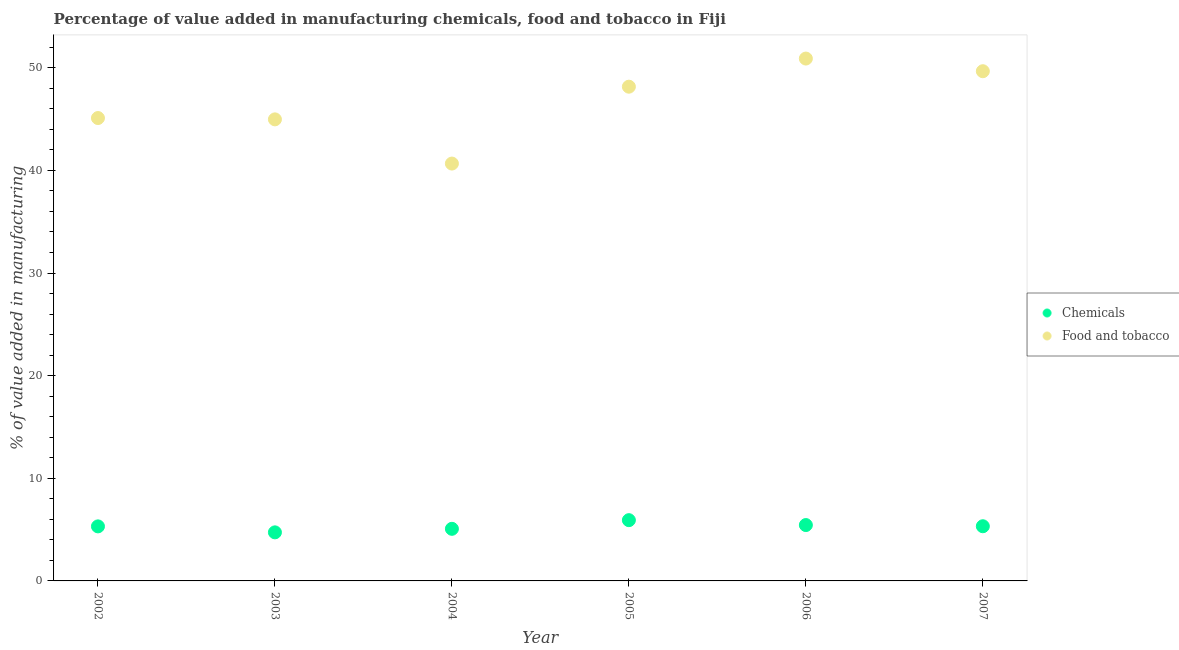How many different coloured dotlines are there?
Ensure brevity in your answer.  2. What is the value added by  manufacturing chemicals in 2003?
Provide a succinct answer. 4.73. Across all years, what is the maximum value added by  manufacturing chemicals?
Provide a short and direct response. 5.92. Across all years, what is the minimum value added by manufacturing food and tobacco?
Provide a succinct answer. 40.67. In which year was the value added by  manufacturing chemicals maximum?
Offer a very short reply. 2005. What is the total value added by  manufacturing chemicals in the graph?
Offer a very short reply. 31.82. What is the difference between the value added by manufacturing food and tobacco in 2002 and that in 2006?
Your answer should be compact. -5.79. What is the difference between the value added by  manufacturing chemicals in 2003 and the value added by manufacturing food and tobacco in 2004?
Your response must be concise. -35.94. What is the average value added by  manufacturing chemicals per year?
Ensure brevity in your answer.  5.3. In the year 2007, what is the difference between the value added by  manufacturing chemicals and value added by manufacturing food and tobacco?
Offer a very short reply. -44.34. In how many years, is the value added by  manufacturing chemicals greater than 46 %?
Your answer should be very brief. 0. What is the ratio of the value added by  manufacturing chemicals in 2005 to that in 2006?
Offer a terse response. 1.09. Is the difference between the value added by  manufacturing chemicals in 2002 and 2005 greater than the difference between the value added by manufacturing food and tobacco in 2002 and 2005?
Your answer should be very brief. Yes. What is the difference between the highest and the second highest value added by  manufacturing chemicals?
Your response must be concise. 0.48. What is the difference between the highest and the lowest value added by manufacturing food and tobacco?
Offer a very short reply. 10.23. Is the sum of the value added by manufacturing food and tobacco in 2002 and 2004 greater than the maximum value added by  manufacturing chemicals across all years?
Keep it short and to the point. Yes. How many dotlines are there?
Keep it short and to the point. 2. How many years are there in the graph?
Your response must be concise. 6. What is the difference between two consecutive major ticks on the Y-axis?
Your answer should be very brief. 10. Where does the legend appear in the graph?
Provide a succinct answer. Center right. How many legend labels are there?
Your answer should be compact. 2. How are the legend labels stacked?
Your answer should be very brief. Vertical. What is the title of the graph?
Make the answer very short. Percentage of value added in manufacturing chemicals, food and tobacco in Fiji. What is the label or title of the X-axis?
Provide a succinct answer. Year. What is the label or title of the Y-axis?
Make the answer very short. % of value added in manufacturing. What is the % of value added in manufacturing of Chemicals in 2002?
Ensure brevity in your answer.  5.31. What is the % of value added in manufacturing of Food and tobacco in 2002?
Your answer should be very brief. 45.1. What is the % of value added in manufacturing of Chemicals in 2003?
Keep it short and to the point. 4.73. What is the % of value added in manufacturing of Food and tobacco in 2003?
Keep it short and to the point. 44.97. What is the % of value added in manufacturing in Chemicals in 2004?
Provide a succinct answer. 5.08. What is the % of value added in manufacturing in Food and tobacco in 2004?
Your answer should be compact. 40.67. What is the % of value added in manufacturing in Chemicals in 2005?
Give a very brief answer. 5.92. What is the % of value added in manufacturing of Food and tobacco in 2005?
Make the answer very short. 48.16. What is the % of value added in manufacturing of Chemicals in 2006?
Provide a short and direct response. 5.44. What is the % of value added in manufacturing in Food and tobacco in 2006?
Offer a terse response. 50.9. What is the % of value added in manufacturing in Chemicals in 2007?
Provide a succinct answer. 5.33. What is the % of value added in manufacturing of Food and tobacco in 2007?
Your response must be concise. 49.67. Across all years, what is the maximum % of value added in manufacturing in Chemicals?
Your answer should be very brief. 5.92. Across all years, what is the maximum % of value added in manufacturing in Food and tobacco?
Offer a very short reply. 50.9. Across all years, what is the minimum % of value added in manufacturing of Chemicals?
Provide a succinct answer. 4.73. Across all years, what is the minimum % of value added in manufacturing of Food and tobacco?
Provide a succinct answer. 40.67. What is the total % of value added in manufacturing in Chemicals in the graph?
Your answer should be very brief. 31.82. What is the total % of value added in manufacturing in Food and tobacco in the graph?
Give a very brief answer. 279.47. What is the difference between the % of value added in manufacturing of Chemicals in 2002 and that in 2003?
Give a very brief answer. 0.58. What is the difference between the % of value added in manufacturing in Food and tobacco in 2002 and that in 2003?
Offer a terse response. 0.13. What is the difference between the % of value added in manufacturing of Chemicals in 2002 and that in 2004?
Your answer should be very brief. 0.24. What is the difference between the % of value added in manufacturing in Food and tobacco in 2002 and that in 2004?
Keep it short and to the point. 4.44. What is the difference between the % of value added in manufacturing in Chemicals in 2002 and that in 2005?
Make the answer very short. -0.61. What is the difference between the % of value added in manufacturing of Food and tobacco in 2002 and that in 2005?
Make the answer very short. -3.05. What is the difference between the % of value added in manufacturing of Chemicals in 2002 and that in 2006?
Your response must be concise. -0.13. What is the difference between the % of value added in manufacturing of Food and tobacco in 2002 and that in 2006?
Your answer should be very brief. -5.79. What is the difference between the % of value added in manufacturing of Chemicals in 2002 and that in 2007?
Make the answer very short. -0.01. What is the difference between the % of value added in manufacturing of Food and tobacco in 2002 and that in 2007?
Offer a terse response. -4.56. What is the difference between the % of value added in manufacturing in Chemicals in 2003 and that in 2004?
Provide a short and direct response. -0.34. What is the difference between the % of value added in manufacturing in Food and tobacco in 2003 and that in 2004?
Your response must be concise. 4.31. What is the difference between the % of value added in manufacturing in Chemicals in 2003 and that in 2005?
Give a very brief answer. -1.19. What is the difference between the % of value added in manufacturing in Food and tobacco in 2003 and that in 2005?
Provide a short and direct response. -3.18. What is the difference between the % of value added in manufacturing in Chemicals in 2003 and that in 2006?
Ensure brevity in your answer.  -0.71. What is the difference between the % of value added in manufacturing of Food and tobacco in 2003 and that in 2006?
Give a very brief answer. -5.92. What is the difference between the % of value added in manufacturing in Chemicals in 2003 and that in 2007?
Keep it short and to the point. -0.6. What is the difference between the % of value added in manufacturing of Food and tobacco in 2003 and that in 2007?
Keep it short and to the point. -4.69. What is the difference between the % of value added in manufacturing in Chemicals in 2004 and that in 2005?
Offer a terse response. -0.84. What is the difference between the % of value added in manufacturing in Food and tobacco in 2004 and that in 2005?
Your answer should be very brief. -7.49. What is the difference between the % of value added in manufacturing in Chemicals in 2004 and that in 2006?
Your answer should be very brief. -0.37. What is the difference between the % of value added in manufacturing of Food and tobacco in 2004 and that in 2006?
Offer a very short reply. -10.23. What is the difference between the % of value added in manufacturing of Chemicals in 2004 and that in 2007?
Provide a succinct answer. -0.25. What is the difference between the % of value added in manufacturing of Food and tobacco in 2004 and that in 2007?
Offer a terse response. -9. What is the difference between the % of value added in manufacturing of Chemicals in 2005 and that in 2006?
Your response must be concise. 0.48. What is the difference between the % of value added in manufacturing in Food and tobacco in 2005 and that in 2006?
Offer a terse response. -2.74. What is the difference between the % of value added in manufacturing of Chemicals in 2005 and that in 2007?
Your answer should be very brief. 0.59. What is the difference between the % of value added in manufacturing in Food and tobacco in 2005 and that in 2007?
Offer a terse response. -1.51. What is the difference between the % of value added in manufacturing of Chemicals in 2006 and that in 2007?
Give a very brief answer. 0.12. What is the difference between the % of value added in manufacturing of Food and tobacco in 2006 and that in 2007?
Your answer should be very brief. 1.23. What is the difference between the % of value added in manufacturing of Chemicals in 2002 and the % of value added in manufacturing of Food and tobacco in 2003?
Give a very brief answer. -39.66. What is the difference between the % of value added in manufacturing in Chemicals in 2002 and the % of value added in manufacturing in Food and tobacco in 2004?
Keep it short and to the point. -35.35. What is the difference between the % of value added in manufacturing in Chemicals in 2002 and the % of value added in manufacturing in Food and tobacco in 2005?
Give a very brief answer. -42.84. What is the difference between the % of value added in manufacturing in Chemicals in 2002 and the % of value added in manufacturing in Food and tobacco in 2006?
Your answer should be very brief. -45.58. What is the difference between the % of value added in manufacturing in Chemicals in 2002 and the % of value added in manufacturing in Food and tobacco in 2007?
Offer a terse response. -44.35. What is the difference between the % of value added in manufacturing of Chemicals in 2003 and the % of value added in manufacturing of Food and tobacco in 2004?
Offer a very short reply. -35.94. What is the difference between the % of value added in manufacturing in Chemicals in 2003 and the % of value added in manufacturing in Food and tobacco in 2005?
Offer a terse response. -43.43. What is the difference between the % of value added in manufacturing in Chemicals in 2003 and the % of value added in manufacturing in Food and tobacco in 2006?
Your answer should be very brief. -46.17. What is the difference between the % of value added in manufacturing of Chemicals in 2003 and the % of value added in manufacturing of Food and tobacco in 2007?
Make the answer very short. -44.93. What is the difference between the % of value added in manufacturing of Chemicals in 2004 and the % of value added in manufacturing of Food and tobacco in 2005?
Your answer should be compact. -43.08. What is the difference between the % of value added in manufacturing in Chemicals in 2004 and the % of value added in manufacturing in Food and tobacco in 2006?
Ensure brevity in your answer.  -45.82. What is the difference between the % of value added in manufacturing in Chemicals in 2004 and the % of value added in manufacturing in Food and tobacco in 2007?
Provide a short and direct response. -44.59. What is the difference between the % of value added in manufacturing in Chemicals in 2005 and the % of value added in manufacturing in Food and tobacco in 2006?
Offer a very short reply. -44.98. What is the difference between the % of value added in manufacturing in Chemicals in 2005 and the % of value added in manufacturing in Food and tobacco in 2007?
Your answer should be very brief. -43.75. What is the difference between the % of value added in manufacturing of Chemicals in 2006 and the % of value added in manufacturing of Food and tobacco in 2007?
Your response must be concise. -44.22. What is the average % of value added in manufacturing in Chemicals per year?
Offer a very short reply. 5.3. What is the average % of value added in manufacturing in Food and tobacco per year?
Make the answer very short. 46.58. In the year 2002, what is the difference between the % of value added in manufacturing in Chemicals and % of value added in manufacturing in Food and tobacco?
Your answer should be very brief. -39.79. In the year 2003, what is the difference between the % of value added in manufacturing of Chemicals and % of value added in manufacturing of Food and tobacco?
Provide a succinct answer. -40.24. In the year 2004, what is the difference between the % of value added in manufacturing in Chemicals and % of value added in manufacturing in Food and tobacco?
Offer a very short reply. -35.59. In the year 2005, what is the difference between the % of value added in manufacturing in Chemicals and % of value added in manufacturing in Food and tobacco?
Provide a short and direct response. -42.24. In the year 2006, what is the difference between the % of value added in manufacturing in Chemicals and % of value added in manufacturing in Food and tobacco?
Provide a short and direct response. -45.45. In the year 2007, what is the difference between the % of value added in manufacturing of Chemicals and % of value added in manufacturing of Food and tobacco?
Provide a short and direct response. -44.34. What is the ratio of the % of value added in manufacturing in Chemicals in 2002 to that in 2003?
Offer a very short reply. 1.12. What is the ratio of the % of value added in manufacturing in Chemicals in 2002 to that in 2004?
Keep it short and to the point. 1.05. What is the ratio of the % of value added in manufacturing in Food and tobacco in 2002 to that in 2004?
Provide a succinct answer. 1.11. What is the ratio of the % of value added in manufacturing in Chemicals in 2002 to that in 2005?
Ensure brevity in your answer.  0.9. What is the ratio of the % of value added in manufacturing of Food and tobacco in 2002 to that in 2005?
Your answer should be compact. 0.94. What is the ratio of the % of value added in manufacturing in Chemicals in 2002 to that in 2006?
Provide a short and direct response. 0.98. What is the ratio of the % of value added in manufacturing in Food and tobacco in 2002 to that in 2006?
Keep it short and to the point. 0.89. What is the ratio of the % of value added in manufacturing of Food and tobacco in 2002 to that in 2007?
Offer a very short reply. 0.91. What is the ratio of the % of value added in manufacturing of Chemicals in 2003 to that in 2004?
Give a very brief answer. 0.93. What is the ratio of the % of value added in manufacturing in Food and tobacco in 2003 to that in 2004?
Provide a short and direct response. 1.11. What is the ratio of the % of value added in manufacturing of Chemicals in 2003 to that in 2005?
Your answer should be compact. 0.8. What is the ratio of the % of value added in manufacturing in Food and tobacco in 2003 to that in 2005?
Your response must be concise. 0.93. What is the ratio of the % of value added in manufacturing in Chemicals in 2003 to that in 2006?
Offer a very short reply. 0.87. What is the ratio of the % of value added in manufacturing in Food and tobacco in 2003 to that in 2006?
Offer a very short reply. 0.88. What is the ratio of the % of value added in manufacturing of Chemicals in 2003 to that in 2007?
Offer a very short reply. 0.89. What is the ratio of the % of value added in manufacturing of Food and tobacco in 2003 to that in 2007?
Your response must be concise. 0.91. What is the ratio of the % of value added in manufacturing of Chemicals in 2004 to that in 2005?
Provide a short and direct response. 0.86. What is the ratio of the % of value added in manufacturing of Food and tobacco in 2004 to that in 2005?
Your answer should be compact. 0.84. What is the ratio of the % of value added in manufacturing in Chemicals in 2004 to that in 2006?
Provide a succinct answer. 0.93. What is the ratio of the % of value added in manufacturing in Food and tobacco in 2004 to that in 2006?
Offer a very short reply. 0.8. What is the ratio of the % of value added in manufacturing in Chemicals in 2004 to that in 2007?
Provide a short and direct response. 0.95. What is the ratio of the % of value added in manufacturing of Food and tobacco in 2004 to that in 2007?
Make the answer very short. 0.82. What is the ratio of the % of value added in manufacturing in Chemicals in 2005 to that in 2006?
Make the answer very short. 1.09. What is the ratio of the % of value added in manufacturing of Food and tobacco in 2005 to that in 2006?
Your answer should be very brief. 0.95. What is the ratio of the % of value added in manufacturing in Chemicals in 2005 to that in 2007?
Make the answer very short. 1.11. What is the ratio of the % of value added in manufacturing of Food and tobacco in 2005 to that in 2007?
Ensure brevity in your answer.  0.97. What is the ratio of the % of value added in manufacturing in Chemicals in 2006 to that in 2007?
Make the answer very short. 1.02. What is the ratio of the % of value added in manufacturing of Food and tobacco in 2006 to that in 2007?
Provide a short and direct response. 1.02. What is the difference between the highest and the second highest % of value added in manufacturing of Chemicals?
Keep it short and to the point. 0.48. What is the difference between the highest and the second highest % of value added in manufacturing of Food and tobacco?
Make the answer very short. 1.23. What is the difference between the highest and the lowest % of value added in manufacturing of Chemicals?
Your answer should be compact. 1.19. What is the difference between the highest and the lowest % of value added in manufacturing in Food and tobacco?
Keep it short and to the point. 10.23. 